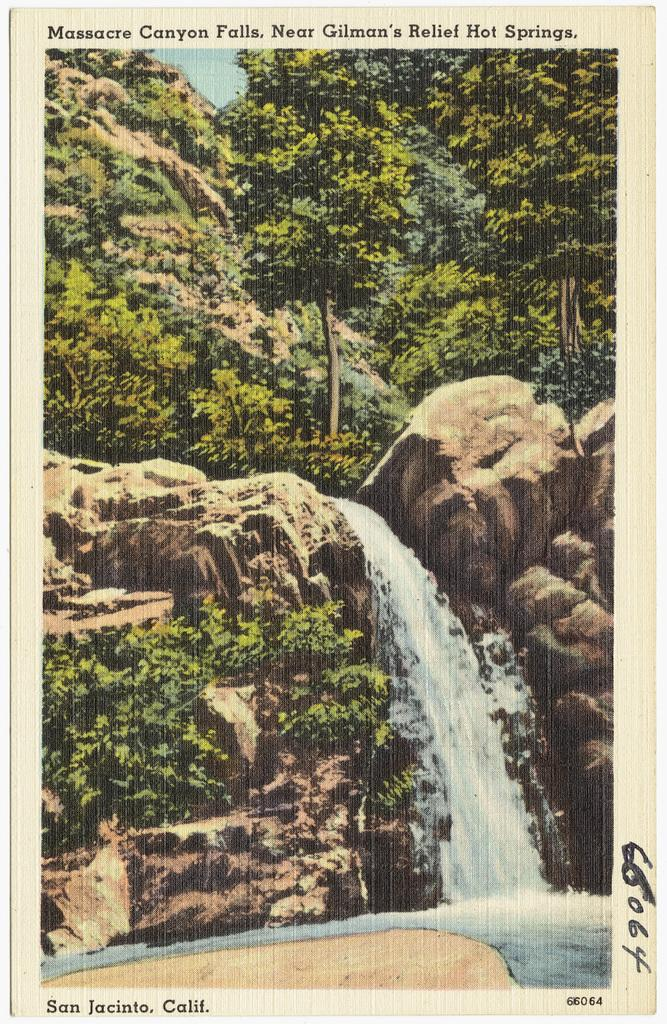What natural feature is the main subject of the picture? There is a waterfall in the picture. What other elements can be seen around the waterfall? Rocks are visible in the picture. What can be seen in the background of the picture? Trees are present in the background of the picture. What is visible in the sky in the picture? Clouds are visible in the sky. Are there any texts or writings in the picture? Yes, there are texts in the picture. What type of shirt is the waterfall wearing in the picture? The waterfall is not a living being and therefore cannot wear a shirt. 